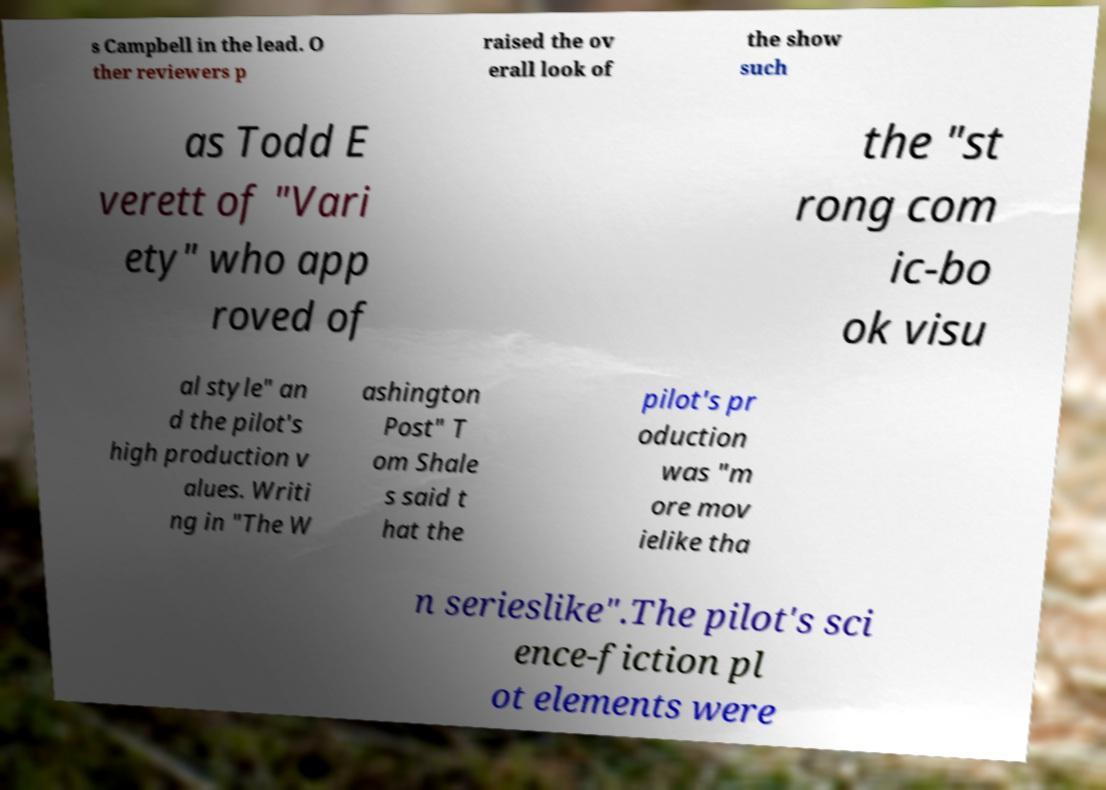Could you assist in decoding the text presented in this image and type it out clearly? s Campbell in the lead. O ther reviewers p raised the ov erall look of the show such as Todd E verett of "Vari ety" who app roved of the "st rong com ic-bo ok visu al style" an d the pilot's high production v alues. Writi ng in "The W ashington Post" T om Shale s said t hat the pilot's pr oduction was "m ore mov ielike tha n serieslike".The pilot's sci ence-fiction pl ot elements were 